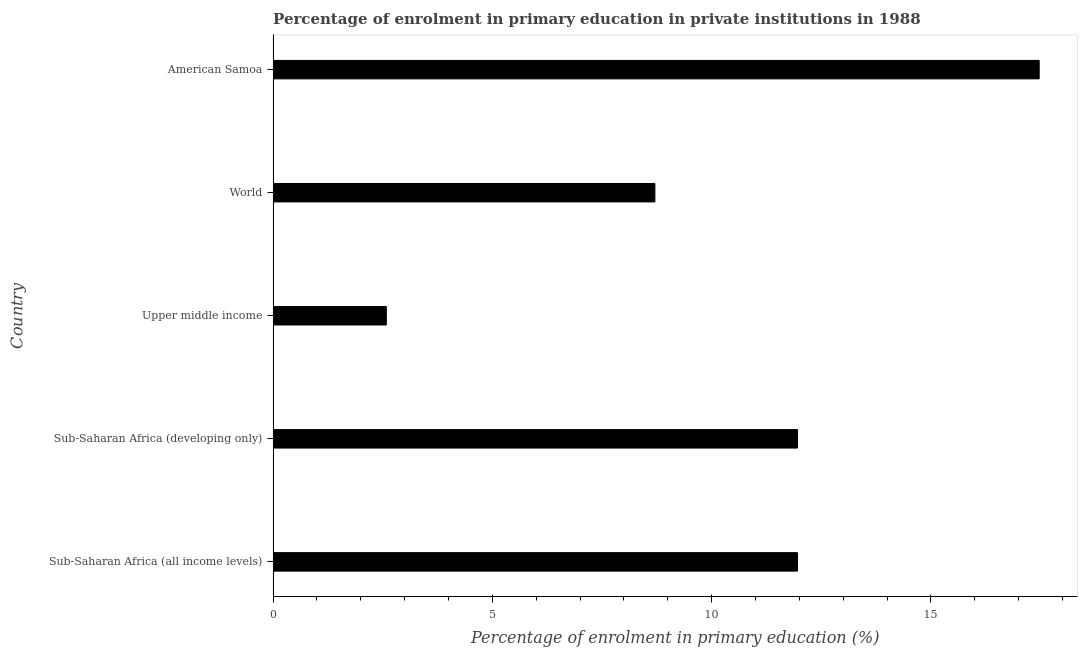What is the title of the graph?
Make the answer very short. Percentage of enrolment in primary education in private institutions in 1988. What is the label or title of the X-axis?
Give a very brief answer. Percentage of enrolment in primary education (%). What is the enrolment percentage in primary education in World?
Give a very brief answer. 8.71. Across all countries, what is the maximum enrolment percentage in primary education?
Offer a very short reply. 17.47. Across all countries, what is the minimum enrolment percentage in primary education?
Make the answer very short. 2.58. In which country was the enrolment percentage in primary education maximum?
Your answer should be compact. American Samoa. In which country was the enrolment percentage in primary education minimum?
Keep it short and to the point. Upper middle income. What is the sum of the enrolment percentage in primary education?
Offer a terse response. 52.68. What is the difference between the enrolment percentage in primary education in American Samoa and Sub-Saharan Africa (all income levels)?
Offer a very short reply. 5.51. What is the average enrolment percentage in primary education per country?
Provide a succinct answer. 10.54. What is the median enrolment percentage in primary education?
Provide a succinct answer. 11.96. What is the ratio of the enrolment percentage in primary education in Sub-Saharan Africa (all income levels) to that in World?
Provide a short and direct response. 1.37. What is the difference between the highest and the second highest enrolment percentage in primary education?
Keep it short and to the point. 5.51. What is the difference between the highest and the lowest enrolment percentage in primary education?
Your answer should be compact. 14.89. In how many countries, is the enrolment percentage in primary education greater than the average enrolment percentage in primary education taken over all countries?
Your response must be concise. 3. How many bars are there?
Make the answer very short. 5. How many countries are there in the graph?
Your answer should be very brief. 5. What is the difference between two consecutive major ticks on the X-axis?
Ensure brevity in your answer.  5. Are the values on the major ticks of X-axis written in scientific E-notation?
Your response must be concise. No. What is the Percentage of enrolment in primary education (%) in Sub-Saharan Africa (all income levels)?
Your response must be concise. 11.96. What is the Percentage of enrolment in primary education (%) in Sub-Saharan Africa (developing only)?
Give a very brief answer. 11.96. What is the Percentage of enrolment in primary education (%) of Upper middle income?
Your response must be concise. 2.58. What is the Percentage of enrolment in primary education (%) of World?
Your answer should be very brief. 8.71. What is the Percentage of enrolment in primary education (%) of American Samoa?
Provide a succinct answer. 17.47. What is the difference between the Percentage of enrolment in primary education (%) in Sub-Saharan Africa (all income levels) and Sub-Saharan Africa (developing only)?
Offer a very short reply. -0. What is the difference between the Percentage of enrolment in primary education (%) in Sub-Saharan Africa (all income levels) and Upper middle income?
Make the answer very short. 9.38. What is the difference between the Percentage of enrolment in primary education (%) in Sub-Saharan Africa (all income levels) and World?
Provide a succinct answer. 3.25. What is the difference between the Percentage of enrolment in primary education (%) in Sub-Saharan Africa (all income levels) and American Samoa?
Provide a short and direct response. -5.51. What is the difference between the Percentage of enrolment in primary education (%) in Sub-Saharan Africa (developing only) and Upper middle income?
Make the answer very short. 9.38. What is the difference between the Percentage of enrolment in primary education (%) in Sub-Saharan Africa (developing only) and World?
Give a very brief answer. 3.25. What is the difference between the Percentage of enrolment in primary education (%) in Sub-Saharan Africa (developing only) and American Samoa?
Offer a terse response. -5.51. What is the difference between the Percentage of enrolment in primary education (%) in Upper middle income and World?
Your answer should be very brief. -6.12. What is the difference between the Percentage of enrolment in primary education (%) in Upper middle income and American Samoa?
Provide a succinct answer. -14.89. What is the difference between the Percentage of enrolment in primary education (%) in World and American Samoa?
Make the answer very short. -8.76. What is the ratio of the Percentage of enrolment in primary education (%) in Sub-Saharan Africa (all income levels) to that in Sub-Saharan Africa (developing only)?
Give a very brief answer. 1. What is the ratio of the Percentage of enrolment in primary education (%) in Sub-Saharan Africa (all income levels) to that in Upper middle income?
Ensure brevity in your answer.  4.63. What is the ratio of the Percentage of enrolment in primary education (%) in Sub-Saharan Africa (all income levels) to that in World?
Keep it short and to the point. 1.37. What is the ratio of the Percentage of enrolment in primary education (%) in Sub-Saharan Africa (all income levels) to that in American Samoa?
Your response must be concise. 0.69. What is the ratio of the Percentage of enrolment in primary education (%) in Sub-Saharan Africa (developing only) to that in Upper middle income?
Offer a terse response. 4.63. What is the ratio of the Percentage of enrolment in primary education (%) in Sub-Saharan Africa (developing only) to that in World?
Provide a succinct answer. 1.37. What is the ratio of the Percentage of enrolment in primary education (%) in Sub-Saharan Africa (developing only) to that in American Samoa?
Keep it short and to the point. 0.69. What is the ratio of the Percentage of enrolment in primary education (%) in Upper middle income to that in World?
Your answer should be very brief. 0.3. What is the ratio of the Percentage of enrolment in primary education (%) in Upper middle income to that in American Samoa?
Your response must be concise. 0.15. What is the ratio of the Percentage of enrolment in primary education (%) in World to that in American Samoa?
Give a very brief answer. 0.5. 